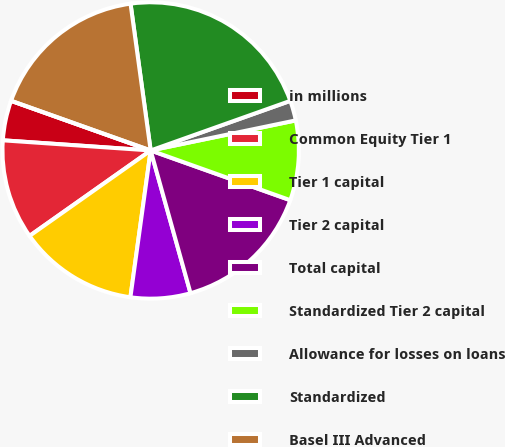Convert chart to OTSL. <chart><loc_0><loc_0><loc_500><loc_500><pie_chart><fcel>in millions<fcel>Common Equity Tier 1<fcel>Tier 1 capital<fcel>Tier 2 capital<fcel>Total capital<fcel>Standardized Tier 2 capital<fcel>Allowance for losses on loans<fcel>Standardized<fcel>Basel III Advanced<fcel>Tier 1 leverage ratio<nl><fcel>4.35%<fcel>10.87%<fcel>13.04%<fcel>6.52%<fcel>15.22%<fcel>8.7%<fcel>2.18%<fcel>21.74%<fcel>17.39%<fcel>0.0%<nl></chart> 